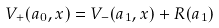Convert formula to latex. <formula><loc_0><loc_0><loc_500><loc_500>V _ { + } ( a _ { 0 } , x ) = V _ { - } ( a _ { 1 } , x ) + R ( a _ { 1 } )</formula> 